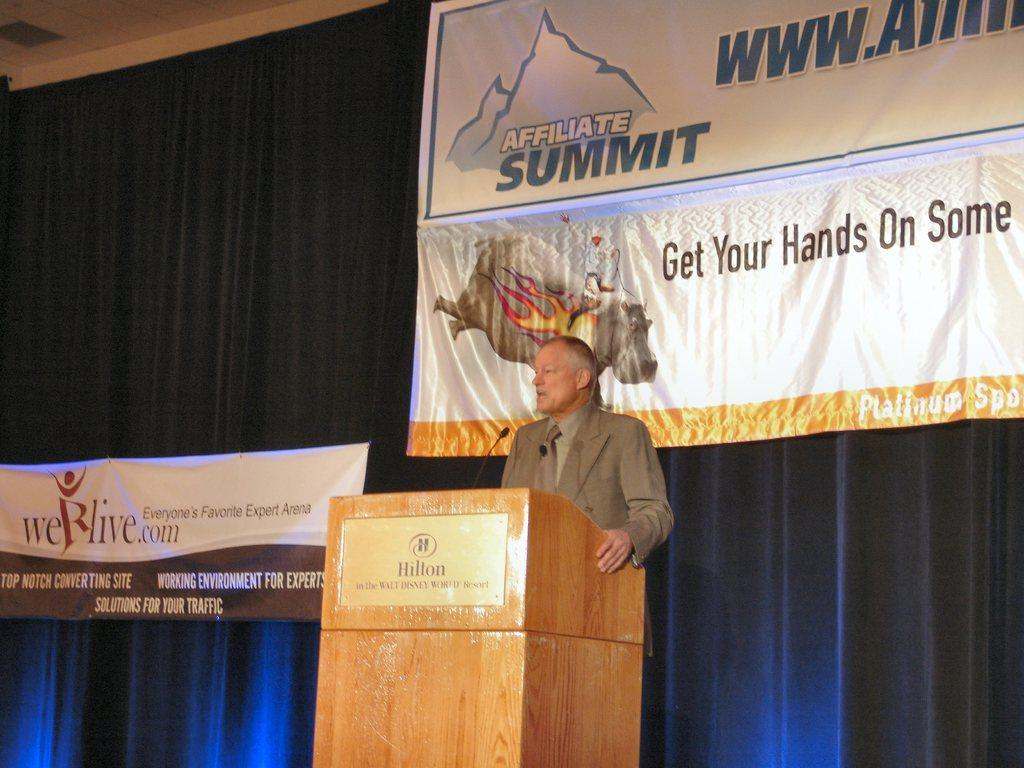What is the man in the image doing? The man appears to be standing behind a table and speaking. Can you describe the man's surroundings in the image? There are two banners in the background of the image, and a curtain is visible behind the banners. What might be the purpose of the banners in the image? The banners could be used for advertising or conveying information. What type of furniture is present in the image? There is no furniture visible in the image, only a man standing behind a table and the background elements. 